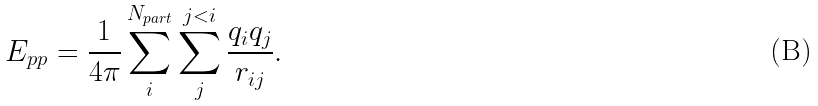Convert formula to latex. <formula><loc_0><loc_0><loc_500><loc_500>E _ { p p } = \frac { 1 } { 4 \pi } \sum _ { i } ^ { N _ { p a r t } } \sum _ { j } ^ { j < i } \frac { q _ { i } q _ { j } } { r _ { i j } } .</formula> 